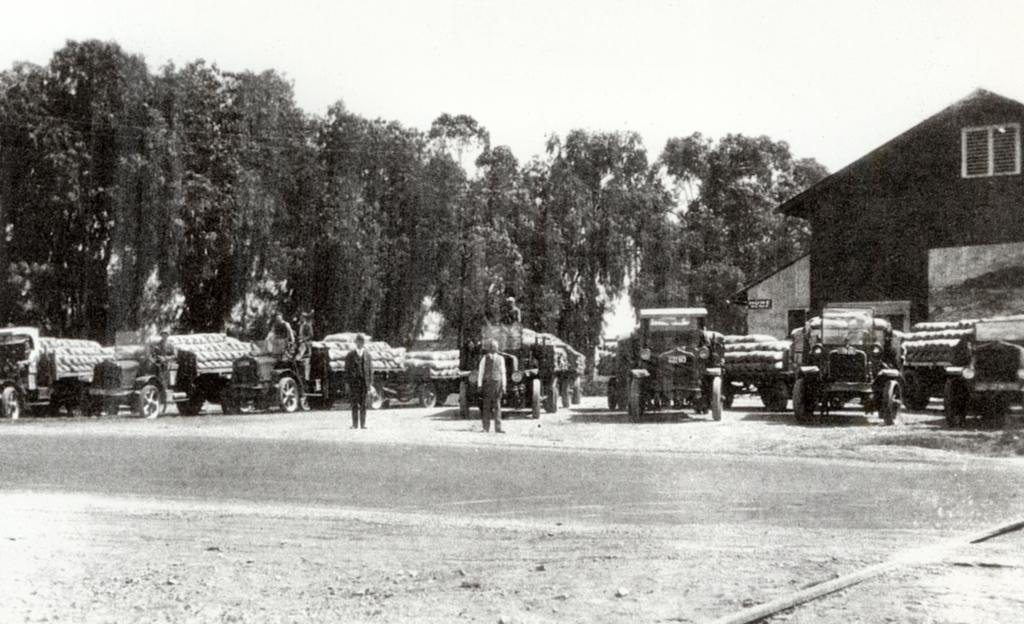What types of objects can be seen in the image? There are vehicles in the image. Are there any living beings present in the image? Yes, there are people standing in the image. What natural elements can be seen in the image? Trees are visible in the image. What type of man-made structure is present in the image? There is a building in the image. What is the color scheme of the image? The image is in black and white. Can you see any signs of a rest or a kiss in the image? There is no indication of a rest or a kiss in the image. What type of afterthought might be associated with the image? The image itself does not suggest any specific afterthought; it simply depicts vehicles, people, trees, a building, and is in black and white. 